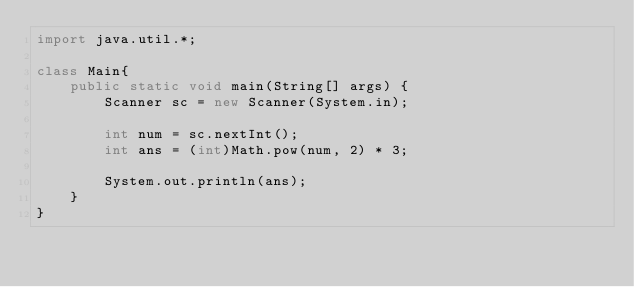Convert code to text. <code><loc_0><loc_0><loc_500><loc_500><_Java_>import java.util.*;

class Main{
    public static void main(String[] args) {
        Scanner sc = new Scanner(System.in);

        int num = sc.nextInt();
        int ans = (int)Math.pow(num, 2) * 3;

        System.out.println(ans);
    }
}</code> 